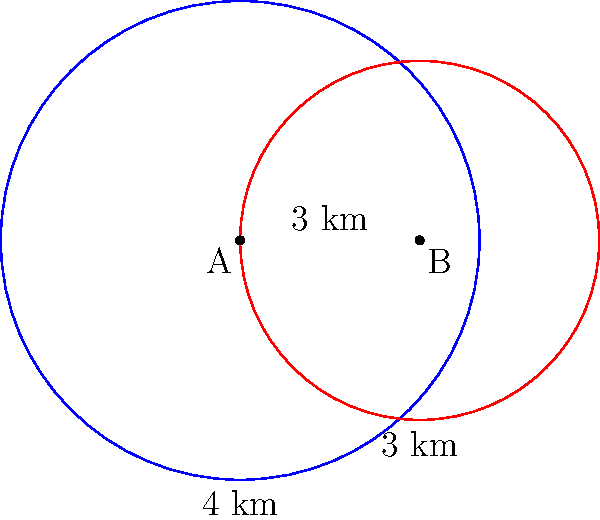Two circular regions of pollutant concentrations have been detected in the ocean. Region A, centered at point A, has a radius of 4 km, while Region B, centered at point B, has a radius of 3 km. The centers of these regions are 3 km apart. Calculate the area of the overlapping region where both pollutants are present. Round your answer to the nearest square kilometer. To solve this problem, we'll use the formula for the area of intersection between two circles. Let's approach this step-by-step:

1) First, we need to calculate the distance between the centers of the circles (d):
   $d = 3$ km (given in the problem)

2) We know the radii of both circles:
   $r_1 = 4$ km (Region A)
   $r_2 = 3$ km (Region B)

3) Now, we'll use the formula for the area of intersection:

   $A = r_1^2 \arccos(\frac{d^2 + r_1^2 - r_2^2}{2dr_1}) + r_2^2 \arccos(\frac{d^2 + r_2^2 - r_1^2}{2dr_2}) - \frac{1}{2}\sqrt{(-d+r_1+r_2)(d+r_1-r_2)(d-r_1+r_2)(d+r_1+r_2)}$

4) Let's substitute our values:

   $A = 4^2 \arccos(\frac{3^2 + 4^2 - 3^2}{2 \cdot 3 \cdot 4}) + 3^2 \arccos(\frac{3^2 + 3^2 - 4^2}{2 \cdot 3 \cdot 3}) - \frac{1}{2}\sqrt{(-3+4+3)(3+4-3)(3-4+3)(3+4+3)}$

5) Simplify:

   $A = 16 \arccos(\frac{25}{24}) + 9 \arccos(\frac{2}{6}) - \frac{1}{2}\sqrt{4 \cdot 4 \cdot 2 \cdot 10}$

6) Calculate:

   $A \approx 16 \cdot 0.2838 + 9 \cdot 1.2490 - \frac{1}{2}\sqrt{320}$
   $A \approx 4.5408 + 11.2410 - 8.9443$
   $A \approx 6.8375$ km²

7) Rounding to the nearest square kilometer:

   $A \approx 7$ km²
Answer: 7 km² 